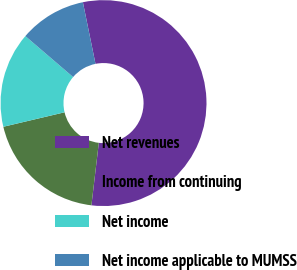Convert chart. <chart><loc_0><loc_0><loc_500><loc_500><pie_chart><fcel>Net revenues<fcel>Income from continuing<fcel>Net income<fcel>Net income applicable to MUMSS<nl><fcel>55.09%<fcel>19.43%<fcel>14.97%<fcel>10.51%<nl></chart> 